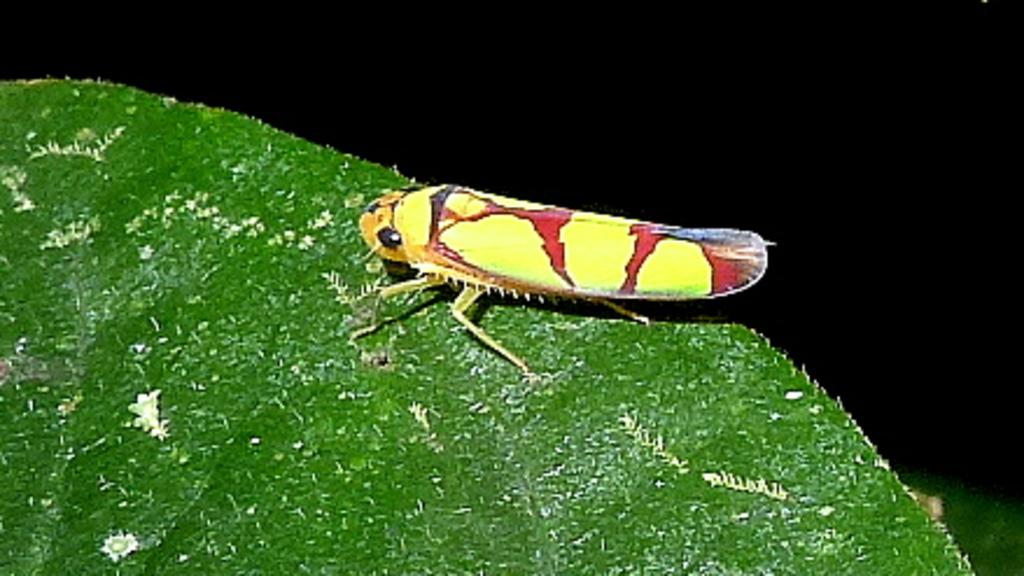What type of creature is in the image? There is an insect in the image. Can you describe the insect's appearance? The insect looks like a grasshopper and has yellow and red coloration. Where is the insect located in the image? The insect is on a green leaf. What is the color of the background in the image? The background of the image is black in color. How does the insect compare to the wristwatch in the image? There is no wristwatch present in the image, so it cannot be compared to the insect. How many snakes are visible in the image? There are no snakes present in the image; it features an insect on a green leaf with a black background. 